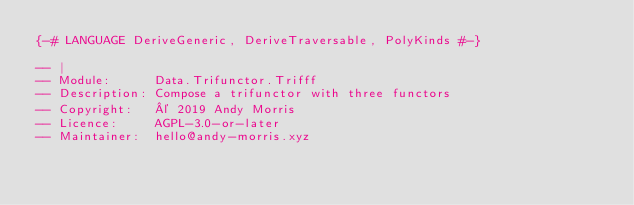Convert code to text. <code><loc_0><loc_0><loc_500><loc_500><_Haskell_>{-# LANGUAGE DeriveGeneric, DeriveTraversable, PolyKinds #-}

-- |
-- Module:      Data.Trifunctor.Trifff
-- Description: Compose a trifunctor with three functors
-- Copyright:   © 2019 Andy Morris
-- Licence:     AGPL-3.0-or-later
-- Maintainer:  hello@andy-morris.xyz</code> 